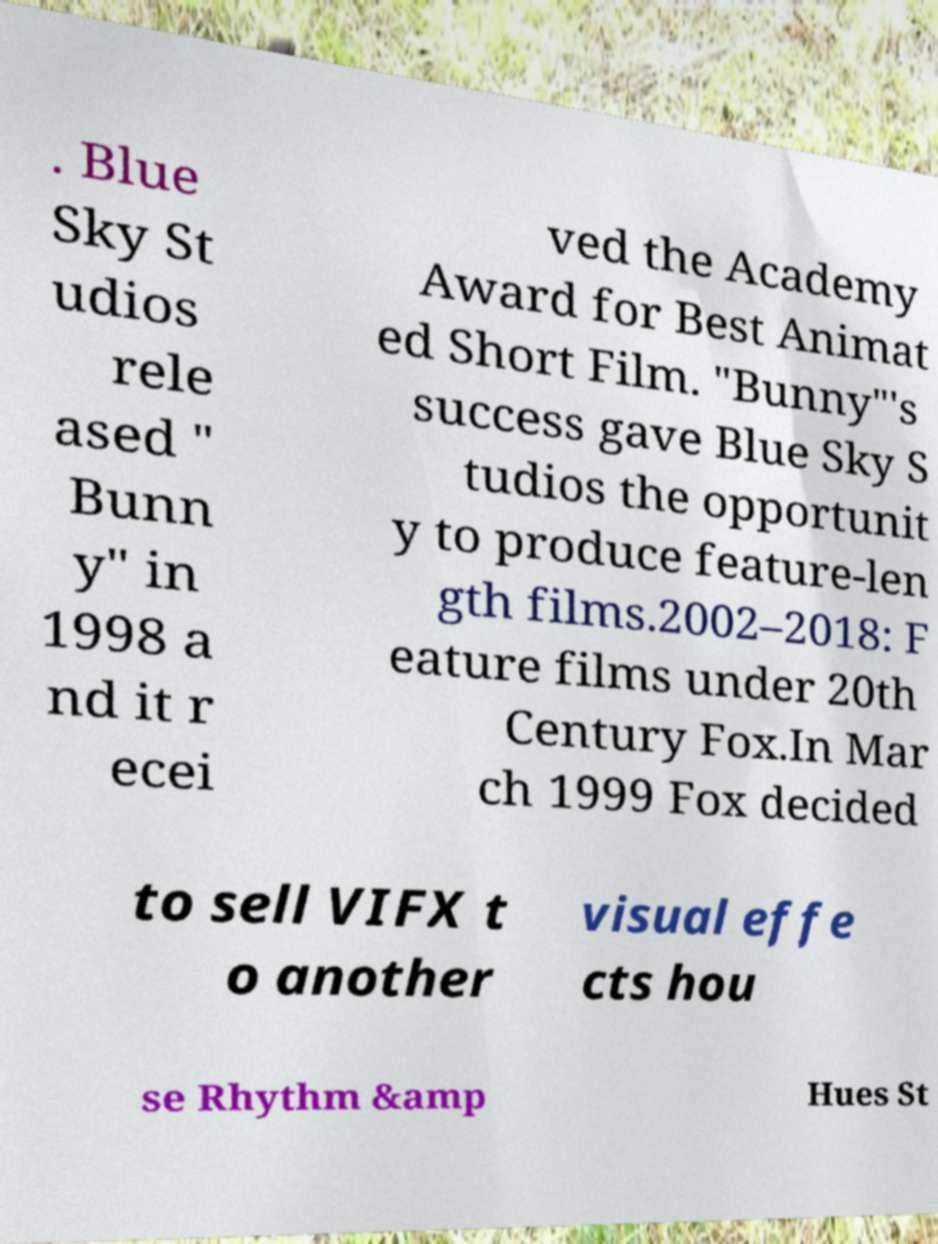Could you assist in decoding the text presented in this image and type it out clearly? . Blue Sky St udios rele ased " Bunn y" in 1998 a nd it r ecei ved the Academy Award for Best Animat ed Short Film. "Bunny"'s success gave Blue Sky S tudios the opportunit y to produce feature-len gth films.2002–2018: F eature films under 20th Century Fox.In Mar ch 1999 Fox decided to sell VIFX t o another visual effe cts hou se Rhythm &amp Hues St 